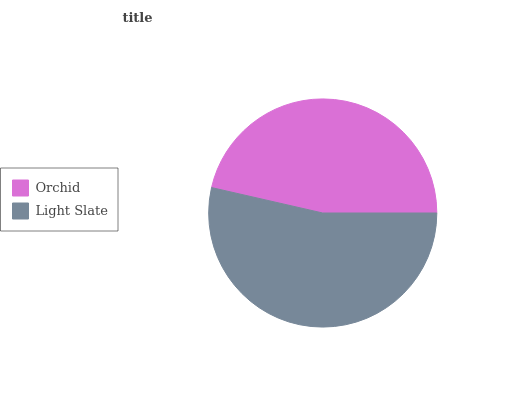Is Orchid the minimum?
Answer yes or no. Yes. Is Light Slate the maximum?
Answer yes or no. Yes. Is Light Slate the minimum?
Answer yes or no. No. Is Light Slate greater than Orchid?
Answer yes or no. Yes. Is Orchid less than Light Slate?
Answer yes or no. Yes. Is Orchid greater than Light Slate?
Answer yes or no. No. Is Light Slate less than Orchid?
Answer yes or no. No. Is Light Slate the high median?
Answer yes or no. Yes. Is Orchid the low median?
Answer yes or no. Yes. Is Orchid the high median?
Answer yes or no. No. Is Light Slate the low median?
Answer yes or no. No. 